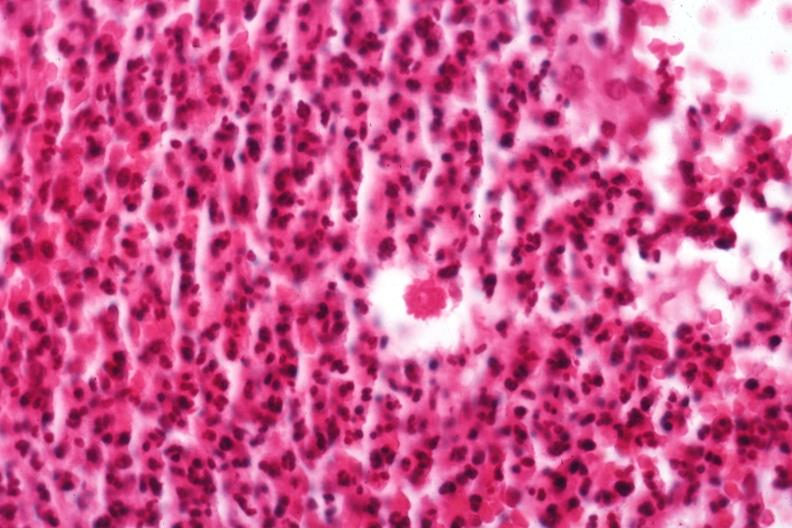where is this?
Answer the question using a single word or phrase. Skin 